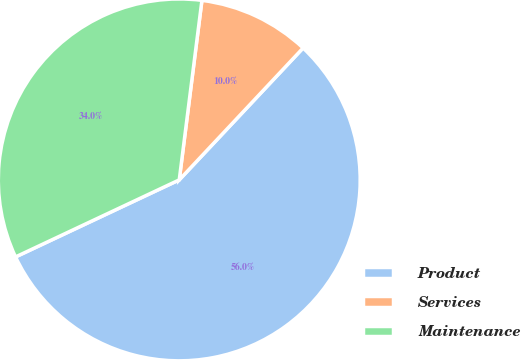<chart> <loc_0><loc_0><loc_500><loc_500><pie_chart><fcel>Product<fcel>Services<fcel>Maintenance<nl><fcel>56.0%<fcel>10.0%<fcel>34.0%<nl></chart> 